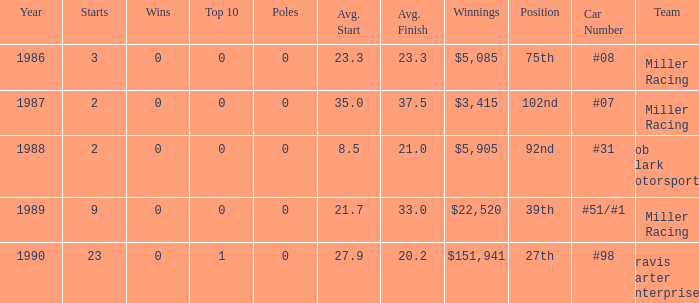How many teams finished in the top team with an average finish of 23.3? 1.0. 